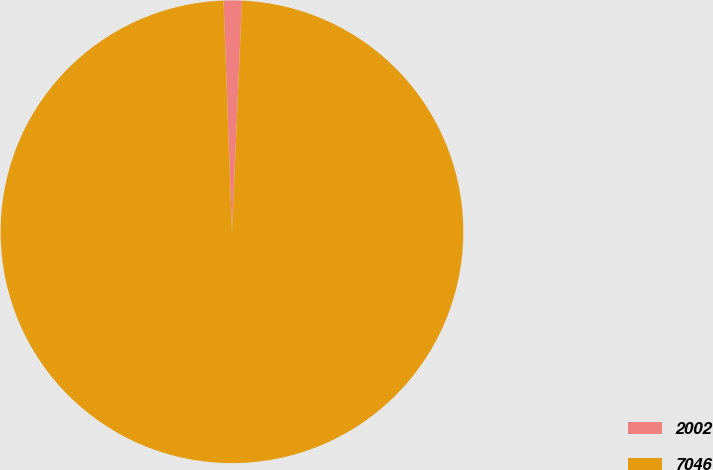Convert chart to OTSL. <chart><loc_0><loc_0><loc_500><loc_500><pie_chart><fcel>2002<fcel>7046<nl><fcel>1.27%<fcel>98.73%<nl></chart> 